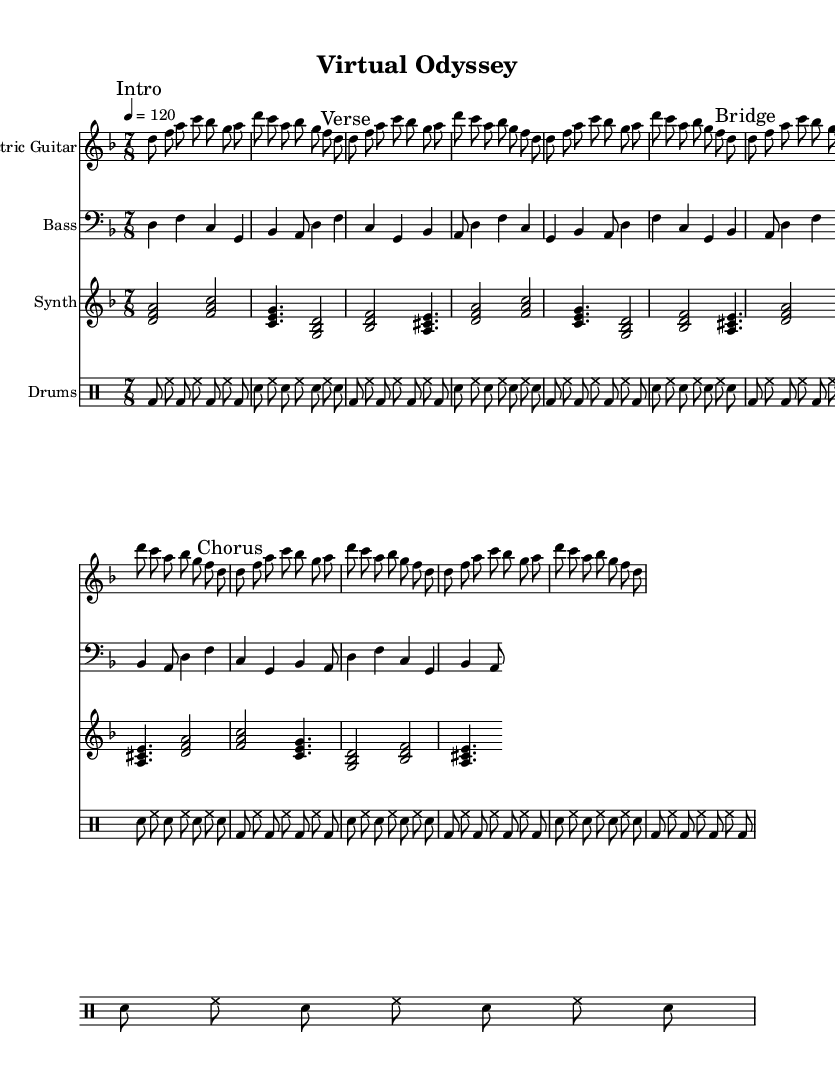What is the key signature of this music? The key signature is indicated by the placement of accidentals and the corresponding note names. In this score, there are no sharps or flats listed, establishing it as D minor, which is relative to F major.
Answer: D minor What is the time signature of this music? The time signature is found at the beginning of the music, which is presented as a fraction. In this case, 7/8 indicates there are seven beats in each measure with an eighth note receiving one beat.
Answer: 7/8 What is the tempo marking for this piece? The tempo marking is located at the start of the score and specifies the speed of the music. Here, it is indicated as "4 = 120", meaning there are 120 quarter note beats per minute.
Answer: 120 How many times is the verse repeated in the electric guitar part? By analyzing the section marked "Verse," it shows the repeat indication mentioned in the score. The verse section is repeated two times as stated in the markings.
Answer: 2 Which instruments are included in this piece? The instruments can be identified from the introductory headers associated with each staff throughout the score. They include Electric Guitar, Bass, Synth, and Drums.
Answer: Electric Guitar, Bass, Synth, Drums What type of rhythm pattern is primarily used by the drums? By examining the drum staff, a repeating pattern incorporates bass drum and snare using eighth notes and a constant hi-hat. This specific arrangement conveys a consistent rock rhythm characteristic of the genre.
Answer: Rock rhythm What is the format of the synth chords? The chords are displayed as stacked notes indicating multiple pitches played simultaneously. The synth part contains triads and includes notes such as D, F, and A, revealing a layered harmonic texture typical in progressive rock.
Answer: Triads 